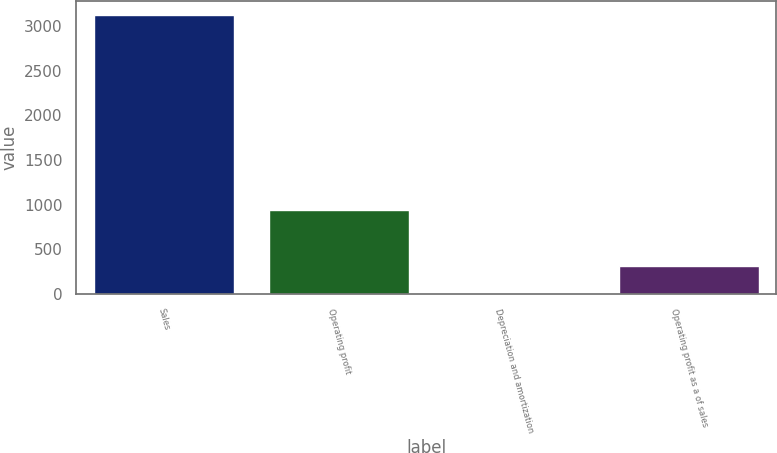Convert chart to OTSL. <chart><loc_0><loc_0><loc_500><loc_500><bar_chart><fcel>Sales<fcel>Operating profit<fcel>Depreciation and amortization<fcel>Operating profit as a of sales<nl><fcel>3121.4<fcel>937.89<fcel>2.1<fcel>314.03<nl></chart> 